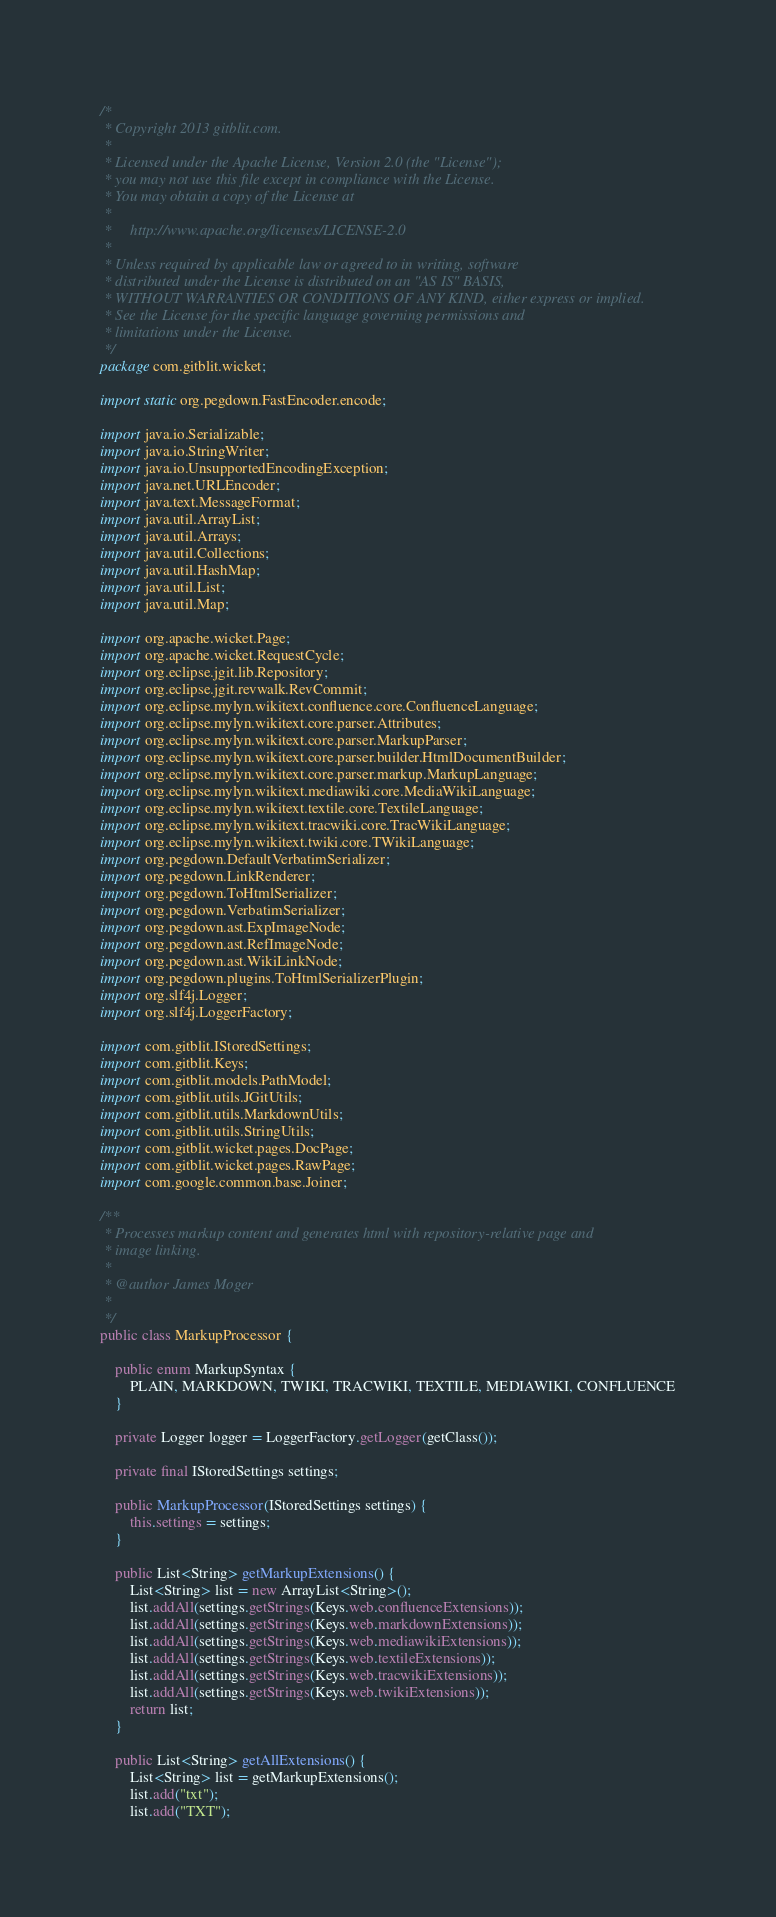<code> <loc_0><loc_0><loc_500><loc_500><_Java_>/*
 * Copyright 2013 gitblit.com.
 *
 * Licensed under the Apache License, Version 2.0 (the "License");
 * you may not use this file except in compliance with the License.
 * You may obtain a copy of the License at
 *
 *     http://www.apache.org/licenses/LICENSE-2.0
 *
 * Unless required by applicable law or agreed to in writing, software
 * distributed under the License is distributed on an "AS IS" BASIS,
 * WITHOUT WARRANTIES OR CONDITIONS OF ANY KIND, either express or implied.
 * See the License for the specific language governing permissions and
 * limitations under the License.
 */
package com.gitblit.wicket;

import static org.pegdown.FastEncoder.encode;

import java.io.Serializable;
import java.io.StringWriter;
import java.io.UnsupportedEncodingException;
import java.net.URLEncoder;
import java.text.MessageFormat;
import java.util.ArrayList;
import java.util.Arrays;
import java.util.Collections;
import java.util.HashMap;
import java.util.List;
import java.util.Map;

import org.apache.wicket.Page;
import org.apache.wicket.RequestCycle;
import org.eclipse.jgit.lib.Repository;
import org.eclipse.jgit.revwalk.RevCommit;
import org.eclipse.mylyn.wikitext.confluence.core.ConfluenceLanguage;
import org.eclipse.mylyn.wikitext.core.parser.Attributes;
import org.eclipse.mylyn.wikitext.core.parser.MarkupParser;
import org.eclipse.mylyn.wikitext.core.parser.builder.HtmlDocumentBuilder;
import org.eclipse.mylyn.wikitext.core.parser.markup.MarkupLanguage;
import org.eclipse.mylyn.wikitext.mediawiki.core.MediaWikiLanguage;
import org.eclipse.mylyn.wikitext.textile.core.TextileLanguage;
import org.eclipse.mylyn.wikitext.tracwiki.core.TracWikiLanguage;
import org.eclipse.mylyn.wikitext.twiki.core.TWikiLanguage;
import org.pegdown.DefaultVerbatimSerializer;
import org.pegdown.LinkRenderer;
import org.pegdown.ToHtmlSerializer;
import org.pegdown.VerbatimSerializer;
import org.pegdown.ast.ExpImageNode;
import org.pegdown.ast.RefImageNode;
import org.pegdown.ast.WikiLinkNode;
import org.pegdown.plugins.ToHtmlSerializerPlugin;
import org.slf4j.Logger;
import org.slf4j.LoggerFactory;

import com.gitblit.IStoredSettings;
import com.gitblit.Keys;
import com.gitblit.models.PathModel;
import com.gitblit.utils.JGitUtils;
import com.gitblit.utils.MarkdownUtils;
import com.gitblit.utils.StringUtils;
import com.gitblit.wicket.pages.DocPage;
import com.gitblit.wicket.pages.RawPage;
import com.google.common.base.Joiner;

/**
 * Processes markup content and generates html with repository-relative page and
 * image linking.
 *
 * @author James Moger
 *
 */
public class MarkupProcessor {

	public enum MarkupSyntax {
		PLAIN, MARKDOWN, TWIKI, TRACWIKI, TEXTILE, MEDIAWIKI, CONFLUENCE
	}

	private Logger logger = LoggerFactory.getLogger(getClass());

	private final IStoredSettings settings;

	public MarkupProcessor(IStoredSettings settings) {
		this.settings = settings;
	}

	public List<String> getMarkupExtensions() {
		List<String> list = new ArrayList<String>();
		list.addAll(settings.getStrings(Keys.web.confluenceExtensions));
		list.addAll(settings.getStrings(Keys.web.markdownExtensions));
		list.addAll(settings.getStrings(Keys.web.mediawikiExtensions));
		list.addAll(settings.getStrings(Keys.web.textileExtensions));
		list.addAll(settings.getStrings(Keys.web.tracwikiExtensions));
		list.addAll(settings.getStrings(Keys.web.twikiExtensions));
		return list;
	}

	public List<String> getAllExtensions() {
		List<String> list = getMarkupExtensions();
		list.add("txt");
		list.add("TXT");</code> 